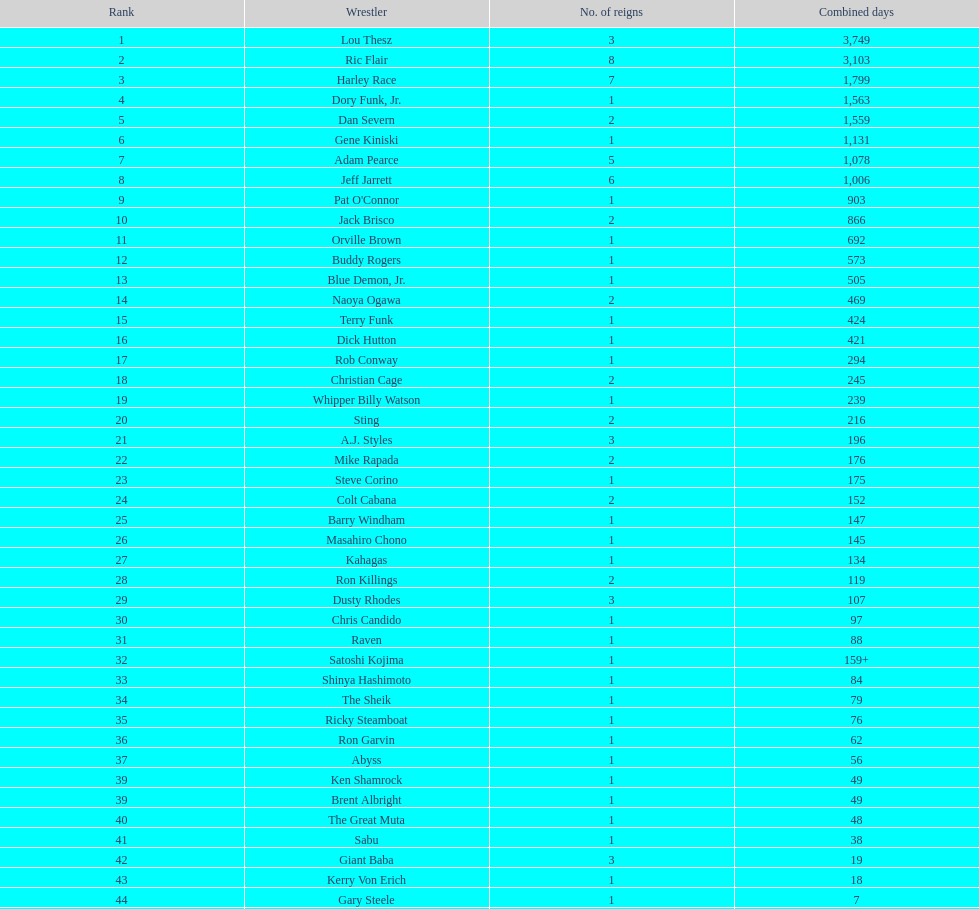Who has spent more time as nwa world heavyyweight champion, gene kiniski or ric flair? Ric Flair. 